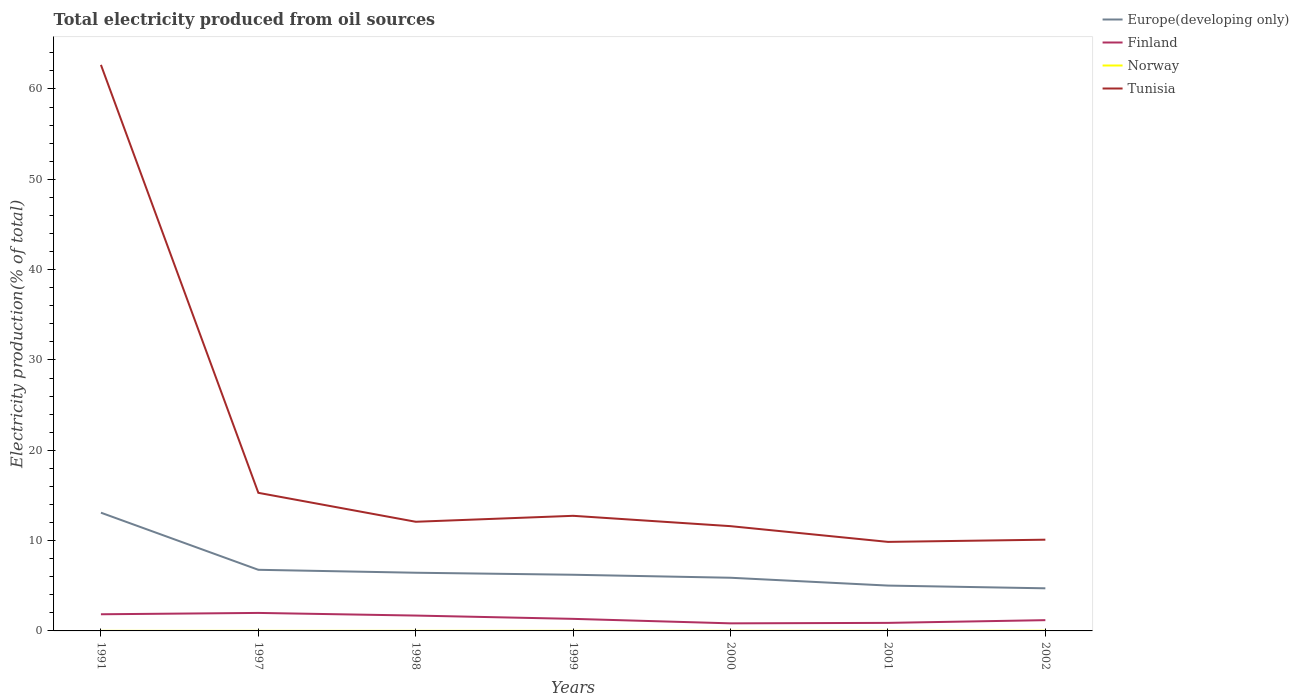How many different coloured lines are there?
Your answer should be very brief. 4. Does the line corresponding to Norway intersect with the line corresponding to Finland?
Keep it short and to the point. No. Across all years, what is the maximum total electricity produced in Norway?
Provide a short and direct response. 0.01. In which year was the total electricity produced in Tunisia maximum?
Give a very brief answer. 2001. What is the total total electricity produced in Finland in the graph?
Keep it short and to the point. -0.05. What is the difference between the highest and the second highest total electricity produced in Norway?
Provide a succinct answer. 0.01. What is the difference between the highest and the lowest total electricity produced in Tunisia?
Provide a short and direct response. 1. Is the total electricity produced in Europe(developing only) strictly greater than the total electricity produced in Norway over the years?
Provide a short and direct response. No. Are the values on the major ticks of Y-axis written in scientific E-notation?
Provide a succinct answer. No. Does the graph contain grids?
Your answer should be very brief. No. Where does the legend appear in the graph?
Offer a very short reply. Top right. How many legend labels are there?
Offer a terse response. 4. What is the title of the graph?
Ensure brevity in your answer.  Total electricity produced from oil sources. Does "Syrian Arab Republic" appear as one of the legend labels in the graph?
Your response must be concise. No. What is the label or title of the Y-axis?
Your answer should be compact. Electricity production(% of total). What is the Electricity production(% of total) of Europe(developing only) in 1991?
Your response must be concise. 13.09. What is the Electricity production(% of total) in Finland in 1991?
Make the answer very short. 1.84. What is the Electricity production(% of total) in Norway in 1991?
Your response must be concise. 0.01. What is the Electricity production(% of total) of Tunisia in 1991?
Provide a short and direct response. 62.67. What is the Electricity production(% of total) of Europe(developing only) in 1997?
Provide a succinct answer. 6.77. What is the Electricity production(% of total) of Finland in 1997?
Your answer should be very brief. 1.99. What is the Electricity production(% of total) of Norway in 1997?
Make the answer very short. 0.01. What is the Electricity production(% of total) in Tunisia in 1997?
Make the answer very short. 15.29. What is the Electricity production(% of total) in Europe(developing only) in 1998?
Provide a succinct answer. 6.44. What is the Electricity production(% of total) in Finland in 1998?
Keep it short and to the point. 1.7. What is the Electricity production(% of total) in Norway in 1998?
Provide a succinct answer. 0.01. What is the Electricity production(% of total) in Tunisia in 1998?
Provide a short and direct response. 12.09. What is the Electricity production(% of total) in Europe(developing only) in 1999?
Offer a very short reply. 6.22. What is the Electricity production(% of total) in Finland in 1999?
Keep it short and to the point. 1.34. What is the Electricity production(% of total) in Norway in 1999?
Your answer should be compact. 0.01. What is the Electricity production(% of total) of Tunisia in 1999?
Your answer should be very brief. 12.74. What is the Electricity production(% of total) of Europe(developing only) in 2000?
Your answer should be compact. 5.89. What is the Electricity production(% of total) of Finland in 2000?
Provide a succinct answer. 0.84. What is the Electricity production(% of total) of Norway in 2000?
Your answer should be compact. 0.01. What is the Electricity production(% of total) in Tunisia in 2000?
Your answer should be compact. 11.6. What is the Electricity production(% of total) in Europe(developing only) in 2001?
Make the answer very short. 5.02. What is the Electricity production(% of total) of Finland in 2001?
Offer a very short reply. 0.89. What is the Electricity production(% of total) in Norway in 2001?
Your response must be concise. 0.01. What is the Electricity production(% of total) of Tunisia in 2001?
Keep it short and to the point. 9.86. What is the Electricity production(% of total) of Europe(developing only) in 2002?
Your answer should be compact. 4.72. What is the Electricity production(% of total) of Finland in 2002?
Offer a terse response. 1.19. What is the Electricity production(% of total) in Norway in 2002?
Give a very brief answer. 0.02. What is the Electricity production(% of total) in Tunisia in 2002?
Your response must be concise. 10.1. Across all years, what is the maximum Electricity production(% of total) in Europe(developing only)?
Offer a terse response. 13.09. Across all years, what is the maximum Electricity production(% of total) in Finland?
Keep it short and to the point. 1.99. Across all years, what is the maximum Electricity production(% of total) in Norway?
Offer a terse response. 0.02. Across all years, what is the maximum Electricity production(% of total) in Tunisia?
Give a very brief answer. 62.67. Across all years, what is the minimum Electricity production(% of total) in Europe(developing only)?
Make the answer very short. 4.72. Across all years, what is the minimum Electricity production(% of total) of Finland?
Keep it short and to the point. 0.84. Across all years, what is the minimum Electricity production(% of total) in Norway?
Offer a terse response. 0.01. Across all years, what is the minimum Electricity production(% of total) of Tunisia?
Your answer should be compact. 9.86. What is the total Electricity production(% of total) of Europe(developing only) in the graph?
Offer a very short reply. 48.14. What is the total Electricity production(% of total) of Finland in the graph?
Your answer should be compact. 9.79. What is the total Electricity production(% of total) in Norway in the graph?
Keep it short and to the point. 0.06. What is the total Electricity production(% of total) in Tunisia in the graph?
Provide a short and direct response. 134.35. What is the difference between the Electricity production(% of total) of Europe(developing only) in 1991 and that in 1997?
Make the answer very short. 6.32. What is the difference between the Electricity production(% of total) in Finland in 1991 and that in 1997?
Offer a very short reply. -0.15. What is the difference between the Electricity production(% of total) of Norway in 1991 and that in 1997?
Your response must be concise. -0. What is the difference between the Electricity production(% of total) of Tunisia in 1991 and that in 1997?
Your answer should be compact. 47.38. What is the difference between the Electricity production(% of total) of Europe(developing only) in 1991 and that in 1998?
Ensure brevity in your answer.  6.65. What is the difference between the Electricity production(% of total) in Finland in 1991 and that in 1998?
Offer a very short reply. 0.14. What is the difference between the Electricity production(% of total) of Tunisia in 1991 and that in 1998?
Give a very brief answer. 50.58. What is the difference between the Electricity production(% of total) in Europe(developing only) in 1991 and that in 1999?
Keep it short and to the point. 6.87. What is the difference between the Electricity production(% of total) of Finland in 1991 and that in 1999?
Keep it short and to the point. 0.51. What is the difference between the Electricity production(% of total) of Norway in 1991 and that in 1999?
Provide a short and direct response. -0. What is the difference between the Electricity production(% of total) in Tunisia in 1991 and that in 1999?
Your answer should be compact. 49.93. What is the difference between the Electricity production(% of total) in Europe(developing only) in 1991 and that in 2000?
Your response must be concise. 7.2. What is the difference between the Electricity production(% of total) in Tunisia in 1991 and that in 2000?
Your answer should be very brief. 51.07. What is the difference between the Electricity production(% of total) in Europe(developing only) in 1991 and that in 2001?
Offer a terse response. 8.07. What is the difference between the Electricity production(% of total) of Finland in 1991 and that in 2001?
Give a very brief answer. 0.95. What is the difference between the Electricity production(% of total) of Norway in 1991 and that in 2001?
Provide a short and direct response. -0. What is the difference between the Electricity production(% of total) in Tunisia in 1991 and that in 2001?
Provide a succinct answer. 52.81. What is the difference between the Electricity production(% of total) in Europe(developing only) in 1991 and that in 2002?
Offer a very short reply. 8.37. What is the difference between the Electricity production(% of total) in Finland in 1991 and that in 2002?
Your response must be concise. 0.65. What is the difference between the Electricity production(% of total) in Norway in 1991 and that in 2002?
Offer a terse response. -0.01. What is the difference between the Electricity production(% of total) in Tunisia in 1991 and that in 2002?
Ensure brevity in your answer.  52.57. What is the difference between the Electricity production(% of total) in Europe(developing only) in 1997 and that in 1998?
Make the answer very short. 0.33. What is the difference between the Electricity production(% of total) of Finland in 1997 and that in 1998?
Provide a succinct answer. 0.29. What is the difference between the Electricity production(% of total) of Norway in 1997 and that in 1998?
Your response must be concise. 0. What is the difference between the Electricity production(% of total) of Tunisia in 1997 and that in 1998?
Give a very brief answer. 3.2. What is the difference between the Electricity production(% of total) in Europe(developing only) in 1997 and that in 1999?
Give a very brief answer. 0.55. What is the difference between the Electricity production(% of total) in Finland in 1997 and that in 1999?
Ensure brevity in your answer.  0.66. What is the difference between the Electricity production(% of total) in Norway in 1997 and that in 1999?
Give a very brief answer. -0. What is the difference between the Electricity production(% of total) in Tunisia in 1997 and that in 1999?
Make the answer very short. 2.55. What is the difference between the Electricity production(% of total) of Finland in 1997 and that in 2000?
Your response must be concise. 1.15. What is the difference between the Electricity production(% of total) in Norway in 1997 and that in 2000?
Offer a terse response. 0. What is the difference between the Electricity production(% of total) in Tunisia in 1997 and that in 2000?
Make the answer very short. 3.69. What is the difference between the Electricity production(% of total) in Europe(developing only) in 1997 and that in 2001?
Your answer should be very brief. 1.75. What is the difference between the Electricity production(% of total) of Finland in 1997 and that in 2001?
Give a very brief answer. 1.1. What is the difference between the Electricity production(% of total) in Norway in 1997 and that in 2001?
Your answer should be compact. -0. What is the difference between the Electricity production(% of total) in Tunisia in 1997 and that in 2001?
Offer a very short reply. 5.43. What is the difference between the Electricity production(% of total) of Europe(developing only) in 1997 and that in 2002?
Keep it short and to the point. 2.05. What is the difference between the Electricity production(% of total) in Finland in 1997 and that in 2002?
Give a very brief answer. 0.8. What is the difference between the Electricity production(% of total) in Norway in 1997 and that in 2002?
Your answer should be compact. -0.01. What is the difference between the Electricity production(% of total) of Tunisia in 1997 and that in 2002?
Offer a very short reply. 5.19. What is the difference between the Electricity production(% of total) of Europe(developing only) in 1998 and that in 1999?
Provide a succinct answer. 0.22. What is the difference between the Electricity production(% of total) of Finland in 1998 and that in 1999?
Ensure brevity in your answer.  0.36. What is the difference between the Electricity production(% of total) of Norway in 1998 and that in 1999?
Your answer should be very brief. -0. What is the difference between the Electricity production(% of total) of Tunisia in 1998 and that in 1999?
Ensure brevity in your answer.  -0.66. What is the difference between the Electricity production(% of total) of Europe(developing only) in 1998 and that in 2000?
Offer a very short reply. 0.55. What is the difference between the Electricity production(% of total) of Finland in 1998 and that in 2000?
Provide a short and direct response. 0.86. What is the difference between the Electricity production(% of total) of Norway in 1998 and that in 2000?
Provide a succinct answer. -0. What is the difference between the Electricity production(% of total) in Tunisia in 1998 and that in 2000?
Your answer should be compact. 0.49. What is the difference between the Electricity production(% of total) in Europe(developing only) in 1998 and that in 2001?
Your answer should be compact. 1.42. What is the difference between the Electricity production(% of total) of Finland in 1998 and that in 2001?
Your answer should be compact. 0.81. What is the difference between the Electricity production(% of total) of Norway in 1998 and that in 2001?
Make the answer very short. -0. What is the difference between the Electricity production(% of total) of Tunisia in 1998 and that in 2001?
Provide a short and direct response. 2.23. What is the difference between the Electricity production(% of total) of Europe(developing only) in 1998 and that in 2002?
Offer a very short reply. 1.72. What is the difference between the Electricity production(% of total) of Finland in 1998 and that in 2002?
Offer a very short reply. 0.51. What is the difference between the Electricity production(% of total) in Norway in 1998 and that in 2002?
Keep it short and to the point. -0.01. What is the difference between the Electricity production(% of total) in Tunisia in 1998 and that in 2002?
Provide a succinct answer. 1.99. What is the difference between the Electricity production(% of total) of Europe(developing only) in 1999 and that in 2000?
Your answer should be compact. 0.33. What is the difference between the Electricity production(% of total) in Finland in 1999 and that in 2000?
Your answer should be very brief. 0.5. What is the difference between the Electricity production(% of total) of Norway in 1999 and that in 2000?
Offer a terse response. 0. What is the difference between the Electricity production(% of total) of Tunisia in 1999 and that in 2000?
Your answer should be compact. 1.15. What is the difference between the Electricity production(% of total) in Europe(developing only) in 1999 and that in 2001?
Offer a terse response. 1.2. What is the difference between the Electricity production(% of total) in Finland in 1999 and that in 2001?
Your answer should be very brief. 0.44. What is the difference between the Electricity production(% of total) in Norway in 1999 and that in 2001?
Ensure brevity in your answer.  0. What is the difference between the Electricity production(% of total) of Tunisia in 1999 and that in 2001?
Give a very brief answer. 2.89. What is the difference between the Electricity production(% of total) in Europe(developing only) in 1999 and that in 2002?
Provide a short and direct response. 1.5. What is the difference between the Electricity production(% of total) in Finland in 1999 and that in 2002?
Provide a succinct answer. 0.14. What is the difference between the Electricity production(% of total) of Norway in 1999 and that in 2002?
Offer a terse response. -0.01. What is the difference between the Electricity production(% of total) of Tunisia in 1999 and that in 2002?
Give a very brief answer. 2.64. What is the difference between the Electricity production(% of total) of Europe(developing only) in 2000 and that in 2001?
Ensure brevity in your answer.  0.87. What is the difference between the Electricity production(% of total) of Finland in 2000 and that in 2001?
Provide a short and direct response. -0.05. What is the difference between the Electricity production(% of total) in Norway in 2000 and that in 2001?
Ensure brevity in your answer.  -0. What is the difference between the Electricity production(% of total) of Tunisia in 2000 and that in 2001?
Your answer should be very brief. 1.74. What is the difference between the Electricity production(% of total) of Europe(developing only) in 2000 and that in 2002?
Your answer should be compact. 1.17. What is the difference between the Electricity production(% of total) of Finland in 2000 and that in 2002?
Ensure brevity in your answer.  -0.35. What is the difference between the Electricity production(% of total) of Norway in 2000 and that in 2002?
Your answer should be compact. -0.01. What is the difference between the Electricity production(% of total) in Tunisia in 2000 and that in 2002?
Make the answer very short. 1.5. What is the difference between the Electricity production(% of total) of Europe(developing only) in 2001 and that in 2002?
Your answer should be compact. 0.3. What is the difference between the Electricity production(% of total) in Finland in 2001 and that in 2002?
Your response must be concise. -0.3. What is the difference between the Electricity production(% of total) of Norway in 2001 and that in 2002?
Your answer should be compact. -0.01. What is the difference between the Electricity production(% of total) of Tunisia in 2001 and that in 2002?
Give a very brief answer. -0.24. What is the difference between the Electricity production(% of total) of Europe(developing only) in 1991 and the Electricity production(% of total) of Finland in 1997?
Ensure brevity in your answer.  11.1. What is the difference between the Electricity production(% of total) of Europe(developing only) in 1991 and the Electricity production(% of total) of Norway in 1997?
Make the answer very short. 13.08. What is the difference between the Electricity production(% of total) of Europe(developing only) in 1991 and the Electricity production(% of total) of Tunisia in 1997?
Offer a terse response. -2.2. What is the difference between the Electricity production(% of total) in Finland in 1991 and the Electricity production(% of total) in Norway in 1997?
Make the answer very short. 1.84. What is the difference between the Electricity production(% of total) of Finland in 1991 and the Electricity production(% of total) of Tunisia in 1997?
Ensure brevity in your answer.  -13.45. What is the difference between the Electricity production(% of total) in Norway in 1991 and the Electricity production(% of total) in Tunisia in 1997?
Give a very brief answer. -15.28. What is the difference between the Electricity production(% of total) of Europe(developing only) in 1991 and the Electricity production(% of total) of Finland in 1998?
Your answer should be very brief. 11.39. What is the difference between the Electricity production(% of total) of Europe(developing only) in 1991 and the Electricity production(% of total) of Norway in 1998?
Provide a short and direct response. 13.08. What is the difference between the Electricity production(% of total) in Europe(developing only) in 1991 and the Electricity production(% of total) in Tunisia in 1998?
Provide a succinct answer. 1. What is the difference between the Electricity production(% of total) of Finland in 1991 and the Electricity production(% of total) of Norway in 1998?
Give a very brief answer. 1.84. What is the difference between the Electricity production(% of total) of Finland in 1991 and the Electricity production(% of total) of Tunisia in 1998?
Provide a short and direct response. -10.24. What is the difference between the Electricity production(% of total) in Norway in 1991 and the Electricity production(% of total) in Tunisia in 1998?
Give a very brief answer. -12.08. What is the difference between the Electricity production(% of total) in Europe(developing only) in 1991 and the Electricity production(% of total) in Finland in 1999?
Your response must be concise. 11.75. What is the difference between the Electricity production(% of total) of Europe(developing only) in 1991 and the Electricity production(% of total) of Norway in 1999?
Provide a short and direct response. 13.08. What is the difference between the Electricity production(% of total) of Europe(developing only) in 1991 and the Electricity production(% of total) of Tunisia in 1999?
Provide a succinct answer. 0.35. What is the difference between the Electricity production(% of total) of Finland in 1991 and the Electricity production(% of total) of Norway in 1999?
Provide a succinct answer. 1.84. What is the difference between the Electricity production(% of total) of Finland in 1991 and the Electricity production(% of total) of Tunisia in 1999?
Your answer should be compact. -10.9. What is the difference between the Electricity production(% of total) of Norway in 1991 and the Electricity production(% of total) of Tunisia in 1999?
Your answer should be very brief. -12.74. What is the difference between the Electricity production(% of total) in Europe(developing only) in 1991 and the Electricity production(% of total) in Finland in 2000?
Your response must be concise. 12.25. What is the difference between the Electricity production(% of total) in Europe(developing only) in 1991 and the Electricity production(% of total) in Norway in 2000?
Your response must be concise. 13.08. What is the difference between the Electricity production(% of total) in Europe(developing only) in 1991 and the Electricity production(% of total) in Tunisia in 2000?
Keep it short and to the point. 1.49. What is the difference between the Electricity production(% of total) in Finland in 1991 and the Electricity production(% of total) in Norway in 2000?
Your answer should be very brief. 1.84. What is the difference between the Electricity production(% of total) in Finland in 1991 and the Electricity production(% of total) in Tunisia in 2000?
Your answer should be compact. -9.76. What is the difference between the Electricity production(% of total) of Norway in 1991 and the Electricity production(% of total) of Tunisia in 2000?
Your answer should be compact. -11.59. What is the difference between the Electricity production(% of total) in Europe(developing only) in 1991 and the Electricity production(% of total) in Finland in 2001?
Your answer should be compact. 12.2. What is the difference between the Electricity production(% of total) of Europe(developing only) in 1991 and the Electricity production(% of total) of Norway in 2001?
Your answer should be compact. 13.08. What is the difference between the Electricity production(% of total) in Europe(developing only) in 1991 and the Electricity production(% of total) in Tunisia in 2001?
Ensure brevity in your answer.  3.23. What is the difference between the Electricity production(% of total) in Finland in 1991 and the Electricity production(% of total) in Norway in 2001?
Ensure brevity in your answer.  1.84. What is the difference between the Electricity production(% of total) in Finland in 1991 and the Electricity production(% of total) in Tunisia in 2001?
Your answer should be very brief. -8.01. What is the difference between the Electricity production(% of total) in Norway in 1991 and the Electricity production(% of total) in Tunisia in 2001?
Offer a very short reply. -9.85. What is the difference between the Electricity production(% of total) in Europe(developing only) in 1991 and the Electricity production(% of total) in Finland in 2002?
Your answer should be compact. 11.9. What is the difference between the Electricity production(% of total) of Europe(developing only) in 1991 and the Electricity production(% of total) of Norway in 2002?
Your answer should be very brief. 13.07. What is the difference between the Electricity production(% of total) in Europe(developing only) in 1991 and the Electricity production(% of total) in Tunisia in 2002?
Your answer should be very brief. 2.99. What is the difference between the Electricity production(% of total) in Finland in 1991 and the Electricity production(% of total) in Norway in 2002?
Provide a short and direct response. 1.83. What is the difference between the Electricity production(% of total) in Finland in 1991 and the Electricity production(% of total) in Tunisia in 2002?
Provide a short and direct response. -8.26. What is the difference between the Electricity production(% of total) in Norway in 1991 and the Electricity production(% of total) in Tunisia in 2002?
Ensure brevity in your answer.  -10.09. What is the difference between the Electricity production(% of total) of Europe(developing only) in 1997 and the Electricity production(% of total) of Finland in 1998?
Your answer should be compact. 5.07. What is the difference between the Electricity production(% of total) in Europe(developing only) in 1997 and the Electricity production(% of total) in Norway in 1998?
Provide a succinct answer. 6.76. What is the difference between the Electricity production(% of total) in Europe(developing only) in 1997 and the Electricity production(% of total) in Tunisia in 1998?
Offer a very short reply. -5.32. What is the difference between the Electricity production(% of total) of Finland in 1997 and the Electricity production(% of total) of Norway in 1998?
Your answer should be compact. 1.99. What is the difference between the Electricity production(% of total) in Finland in 1997 and the Electricity production(% of total) in Tunisia in 1998?
Provide a succinct answer. -10.09. What is the difference between the Electricity production(% of total) in Norway in 1997 and the Electricity production(% of total) in Tunisia in 1998?
Provide a succinct answer. -12.08. What is the difference between the Electricity production(% of total) in Europe(developing only) in 1997 and the Electricity production(% of total) in Finland in 1999?
Provide a succinct answer. 5.43. What is the difference between the Electricity production(% of total) of Europe(developing only) in 1997 and the Electricity production(% of total) of Norway in 1999?
Make the answer very short. 6.76. What is the difference between the Electricity production(% of total) in Europe(developing only) in 1997 and the Electricity production(% of total) in Tunisia in 1999?
Provide a succinct answer. -5.98. What is the difference between the Electricity production(% of total) of Finland in 1997 and the Electricity production(% of total) of Norway in 1999?
Give a very brief answer. 1.98. What is the difference between the Electricity production(% of total) of Finland in 1997 and the Electricity production(% of total) of Tunisia in 1999?
Your answer should be very brief. -10.75. What is the difference between the Electricity production(% of total) of Norway in 1997 and the Electricity production(% of total) of Tunisia in 1999?
Your response must be concise. -12.74. What is the difference between the Electricity production(% of total) in Europe(developing only) in 1997 and the Electricity production(% of total) in Finland in 2000?
Make the answer very short. 5.93. What is the difference between the Electricity production(% of total) in Europe(developing only) in 1997 and the Electricity production(% of total) in Norway in 2000?
Provide a short and direct response. 6.76. What is the difference between the Electricity production(% of total) of Europe(developing only) in 1997 and the Electricity production(% of total) of Tunisia in 2000?
Your response must be concise. -4.83. What is the difference between the Electricity production(% of total) in Finland in 1997 and the Electricity production(% of total) in Norway in 2000?
Ensure brevity in your answer.  1.99. What is the difference between the Electricity production(% of total) in Finland in 1997 and the Electricity production(% of total) in Tunisia in 2000?
Keep it short and to the point. -9.61. What is the difference between the Electricity production(% of total) in Norway in 1997 and the Electricity production(% of total) in Tunisia in 2000?
Your answer should be compact. -11.59. What is the difference between the Electricity production(% of total) in Europe(developing only) in 1997 and the Electricity production(% of total) in Finland in 2001?
Offer a terse response. 5.88. What is the difference between the Electricity production(% of total) in Europe(developing only) in 1997 and the Electricity production(% of total) in Norway in 2001?
Provide a short and direct response. 6.76. What is the difference between the Electricity production(% of total) of Europe(developing only) in 1997 and the Electricity production(% of total) of Tunisia in 2001?
Ensure brevity in your answer.  -3.09. What is the difference between the Electricity production(% of total) in Finland in 1997 and the Electricity production(% of total) in Norway in 2001?
Your response must be concise. 1.98. What is the difference between the Electricity production(% of total) of Finland in 1997 and the Electricity production(% of total) of Tunisia in 2001?
Your response must be concise. -7.87. What is the difference between the Electricity production(% of total) in Norway in 1997 and the Electricity production(% of total) in Tunisia in 2001?
Provide a short and direct response. -9.85. What is the difference between the Electricity production(% of total) in Europe(developing only) in 1997 and the Electricity production(% of total) in Finland in 2002?
Make the answer very short. 5.58. What is the difference between the Electricity production(% of total) of Europe(developing only) in 1997 and the Electricity production(% of total) of Norway in 2002?
Make the answer very short. 6.75. What is the difference between the Electricity production(% of total) of Europe(developing only) in 1997 and the Electricity production(% of total) of Tunisia in 2002?
Give a very brief answer. -3.33. What is the difference between the Electricity production(% of total) in Finland in 1997 and the Electricity production(% of total) in Norway in 2002?
Provide a short and direct response. 1.98. What is the difference between the Electricity production(% of total) of Finland in 1997 and the Electricity production(% of total) of Tunisia in 2002?
Your answer should be very brief. -8.11. What is the difference between the Electricity production(% of total) of Norway in 1997 and the Electricity production(% of total) of Tunisia in 2002?
Your answer should be very brief. -10.09. What is the difference between the Electricity production(% of total) of Europe(developing only) in 1998 and the Electricity production(% of total) of Finland in 1999?
Keep it short and to the point. 5.11. What is the difference between the Electricity production(% of total) of Europe(developing only) in 1998 and the Electricity production(% of total) of Norway in 1999?
Offer a terse response. 6.43. What is the difference between the Electricity production(% of total) of Europe(developing only) in 1998 and the Electricity production(% of total) of Tunisia in 1999?
Provide a short and direct response. -6.3. What is the difference between the Electricity production(% of total) in Finland in 1998 and the Electricity production(% of total) in Norway in 1999?
Give a very brief answer. 1.69. What is the difference between the Electricity production(% of total) in Finland in 1998 and the Electricity production(% of total) in Tunisia in 1999?
Ensure brevity in your answer.  -11.04. What is the difference between the Electricity production(% of total) of Norway in 1998 and the Electricity production(% of total) of Tunisia in 1999?
Your answer should be very brief. -12.74. What is the difference between the Electricity production(% of total) of Europe(developing only) in 1998 and the Electricity production(% of total) of Finland in 2000?
Offer a terse response. 5.6. What is the difference between the Electricity production(% of total) of Europe(developing only) in 1998 and the Electricity production(% of total) of Norway in 2000?
Your response must be concise. 6.44. What is the difference between the Electricity production(% of total) in Europe(developing only) in 1998 and the Electricity production(% of total) in Tunisia in 2000?
Ensure brevity in your answer.  -5.16. What is the difference between the Electricity production(% of total) of Finland in 1998 and the Electricity production(% of total) of Norway in 2000?
Your answer should be compact. 1.69. What is the difference between the Electricity production(% of total) of Finland in 1998 and the Electricity production(% of total) of Tunisia in 2000?
Give a very brief answer. -9.9. What is the difference between the Electricity production(% of total) in Norway in 1998 and the Electricity production(% of total) in Tunisia in 2000?
Offer a very short reply. -11.59. What is the difference between the Electricity production(% of total) in Europe(developing only) in 1998 and the Electricity production(% of total) in Finland in 2001?
Ensure brevity in your answer.  5.55. What is the difference between the Electricity production(% of total) of Europe(developing only) in 1998 and the Electricity production(% of total) of Norway in 2001?
Provide a short and direct response. 6.43. What is the difference between the Electricity production(% of total) in Europe(developing only) in 1998 and the Electricity production(% of total) in Tunisia in 2001?
Provide a short and direct response. -3.42. What is the difference between the Electricity production(% of total) in Finland in 1998 and the Electricity production(% of total) in Norway in 2001?
Provide a short and direct response. 1.69. What is the difference between the Electricity production(% of total) of Finland in 1998 and the Electricity production(% of total) of Tunisia in 2001?
Your answer should be very brief. -8.16. What is the difference between the Electricity production(% of total) of Norway in 1998 and the Electricity production(% of total) of Tunisia in 2001?
Provide a short and direct response. -9.85. What is the difference between the Electricity production(% of total) in Europe(developing only) in 1998 and the Electricity production(% of total) in Finland in 2002?
Make the answer very short. 5.25. What is the difference between the Electricity production(% of total) of Europe(developing only) in 1998 and the Electricity production(% of total) of Norway in 2002?
Offer a very short reply. 6.42. What is the difference between the Electricity production(% of total) in Europe(developing only) in 1998 and the Electricity production(% of total) in Tunisia in 2002?
Make the answer very short. -3.66. What is the difference between the Electricity production(% of total) in Finland in 1998 and the Electricity production(% of total) in Norway in 2002?
Provide a succinct answer. 1.68. What is the difference between the Electricity production(% of total) of Finland in 1998 and the Electricity production(% of total) of Tunisia in 2002?
Provide a succinct answer. -8.4. What is the difference between the Electricity production(% of total) in Norway in 1998 and the Electricity production(% of total) in Tunisia in 2002?
Provide a short and direct response. -10.09. What is the difference between the Electricity production(% of total) of Europe(developing only) in 1999 and the Electricity production(% of total) of Finland in 2000?
Provide a succinct answer. 5.38. What is the difference between the Electricity production(% of total) in Europe(developing only) in 1999 and the Electricity production(% of total) in Norway in 2000?
Provide a succinct answer. 6.21. What is the difference between the Electricity production(% of total) in Europe(developing only) in 1999 and the Electricity production(% of total) in Tunisia in 2000?
Give a very brief answer. -5.38. What is the difference between the Electricity production(% of total) in Finland in 1999 and the Electricity production(% of total) in Norway in 2000?
Your answer should be compact. 1.33. What is the difference between the Electricity production(% of total) of Finland in 1999 and the Electricity production(% of total) of Tunisia in 2000?
Your answer should be very brief. -10.26. What is the difference between the Electricity production(% of total) of Norway in 1999 and the Electricity production(% of total) of Tunisia in 2000?
Your response must be concise. -11.59. What is the difference between the Electricity production(% of total) of Europe(developing only) in 1999 and the Electricity production(% of total) of Finland in 2001?
Your response must be concise. 5.33. What is the difference between the Electricity production(% of total) of Europe(developing only) in 1999 and the Electricity production(% of total) of Norway in 2001?
Give a very brief answer. 6.21. What is the difference between the Electricity production(% of total) of Europe(developing only) in 1999 and the Electricity production(% of total) of Tunisia in 2001?
Provide a short and direct response. -3.64. What is the difference between the Electricity production(% of total) of Finland in 1999 and the Electricity production(% of total) of Norway in 2001?
Give a very brief answer. 1.33. What is the difference between the Electricity production(% of total) in Finland in 1999 and the Electricity production(% of total) in Tunisia in 2001?
Make the answer very short. -8.52. What is the difference between the Electricity production(% of total) in Norway in 1999 and the Electricity production(% of total) in Tunisia in 2001?
Provide a short and direct response. -9.85. What is the difference between the Electricity production(% of total) in Europe(developing only) in 1999 and the Electricity production(% of total) in Finland in 2002?
Provide a succinct answer. 5.03. What is the difference between the Electricity production(% of total) of Europe(developing only) in 1999 and the Electricity production(% of total) of Norway in 2002?
Provide a short and direct response. 6.2. What is the difference between the Electricity production(% of total) in Europe(developing only) in 1999 and the Electricity production(% of total) in Tunisia in 2002?
Keep it short and to the point. -3.88. What is the difference between the Electricity production(% of total) of Finland in 1999 and the Electricity production(% of total) of Norway in 2002?
Keep it short and to the point. 1.32. What is the difference between the Electricity production(% of total) in Finland in 1999 and the Electricity production(% of total) in Tunisia in 2002?
Ensure brevity in your answer.  -8.76. What is the difference between the Electricity production(% of total) in Norway in 1999 and the Electricity production(% of total) in Tunisia in 2002?
Make the answer very short. -10.09. What is the difference between the Electricity production(% of total) in Europe(developing only) in 2000 and the Electricity production(% of total) in Finland in 2001?
Your response must be concise. 5. What is the difference between the Electricity production(% of total) of Europe(developing only) in 2000 and the Electricity production(% of total) of Norway in 2001?
Provide a short and direct response. 5.88. What is the difference between the Electricity production(% of total) in Europe(developing only) in 2000 and the Electricity production(% of total) in Tunisia in 2001?
Offer a very short reply. -3.97. What is the difference between the Electricity production(% of total) in Finland in 2000 and the Electricity production(% of total) in Norway in 2001?
Give a very brief answer. 0.83. What is the difference between the Electricity production(% of total) of Finland in 2000 and the Electricity production(% of total) of Tunisia in 2001?
Offer a terse response. -9.02. What is the difference between the Electricity production(% of total) in Norway in 2000 and the Electricity production(% of total) in Tunisia in 2001?
Keep it short and to the point. -9.85. What is the difference between the Electricity production(% of total) in Europe(developing only) in 2000 and the Electricity production(% of total) in Finland in 2002?
Offer a very short reply. 4.7. What is the difference between the Electricity production(% of total) of Europe(developing only) in 2000 and the Electricity production(% of total) of Norway in 2002?
Your answer should be compact. 5.87. What is the difference between the Electricity production(% of total) of Europe(developing only) in 2000 and the Electricity production(% of total) of Tunisia in 2002?
Offer a very short reply. -4.21. What is the difference between the Electricity production(% of total) of Finland in 2000 and the Electricity production(% of total) of Norway in 2002?
Provide a short and direct response. 0.82. What is the difference between the Electricity production(% of total) of Finland in 2000 and the Electricity production(% of total) of Tunisia in 2002?
Provide a short and direct response. -9.26. What is the difference between the Electricity production(% of total) of Norway in 2000 and the Electricity production(% of total) of Tunisia in 2002?
Offer a very short reply. -10.09. What is the difference between the Electricity production(% of total) of Europe(developing only) in 2001 and the Electricity production(% of total) of Finland in 2002?
Your answer should be compact. 3.83. What is the difference between the Electricity production(% of total) of Europe(developing only) in 2001 and the Electricity production(% of total) of Norway in 2002?
Make the answer very short. 5. What is the difference between the Electricity production(% of total) of Europe(developing only) in 2001 and the Electricity production(% of total) of Tunisia in 2002?
Offer a very short reply. -5.08. What is the difference between the Electricity production(% of total) in Finland in 2001 and the Electricity production(% of total) in Norway in 2002?
Make the answer very short. 0.87. What is the difference between the Electricity production(% of total) in Finland in 2001 and the Electricity production(% of total) in Tunisia in 2002?
Give a very brief answer. -9.21. What is the difference between the Electricity production(% of total) of Norway in 2001 and the Electricity production(% of total) of Tunisia in 2002?
Offer a terse response. -10.09. What is the average Electricity production(% of total) in Europe(developing only) per year?
Ensure brevity in your answer.  6.88. What is the average Electricity production(% of total) of Finland per year?
Offer a very short reply. 1.4. What is the average Electricity production(% of total) in Norway per year?
Ensure brevity in your answer.  0.01. What is the average Electricity production(% of total) in Tunisia per year?
Offer a terse response. 19.19. In the year 1991, what is the difference between the Electricity production(% of total) in Europe(developing only) and Electricity production(% of total) in Finland?
Keep it short and to the point. 11.25. In the year 1991, what is the difference between the Electricity production(% of total) of Europe(developing only) and Electricity production(% of total) of Norway?
Provide a succinct answer. 13.08. In the year 1991, what is the difference between the Electricity production(% of total) of Europe(developing only) and Electricity production(% of total) of Tunisia?
Offer a terse response. -49.58. In the year 1991, what is the difference between the Electricity production(% of total) of Finland and Electricity production(% of total) of Norway?
Give a very brief answer. 1.84. In the year 1991, what is the difference between the Electricity production(% of total) in Finland and Electricity production(% of total) in Tunisia?
Give a very brief answer. -60.83. In the year 1991, what is the difference between the Electricity production(% of total) in Norway and Electricity production(% of total) in Tunisia?
Offer a terse response. -62.66. In the year 1997, what is the difference between the Electricity production(% of total) of Europe(developing only) and Electricity production(% of total) of Finland?
Your answer should be very brief. 4.78. In the year 1997, what is the difference between the Electricity production(% of total) of Europe(developing only) and Electricity production(% of total) of Norway?
Give a very brief answer. 6.76. In the year 1997, what is the difference between the Electricity production(% of total) of Europe(developing only) and Electricity production(% of total) of Tunisia?
Your answer should be very brief. -8.52. In the year 1997, what is the difference between the Electricity production(% of total) of Finland and Electricity production(% of total) of Norway?
Provide a succinct answer. 1.98. In the year 1997, what is the difference between the Electricity production(% of total) of Finland and Electricity production(% of total) of Tunisia?
Keep it short and to the point. -13.3. In the year 1997, what is the difference between the Electricity production(% of total) in Norway and Electricity production(% of total) in Tunisia?
Offer a very short reply. -15.28. In the year 1998, what is the difference between the Electricity production(% of total) in Europe(developing only) and Electricity production(% of total) in Finland?
Make the answer very short. 4.74. In the year 1998, what is the difference between the Electricity production(% of total) in Europe(developing only) and Electricity production(% of total) in Norway?
Your answer should be very brief. 6.44. In the year 1998, what is the difference between the Electricity production(% of total) in Europe(developing only) and Electricity production(% of total) in Tunisia?
Offer a terse response. -5.64. In the year 1998, what is the difference between the Electricity production(% of total) of Finland and Electricity production(% of total) of Norway?
Make the answer very short. 1.69. In the year 1998, what is the difference between the Electricity production(% of total) of Finland and Electricity production(% of total) of Tunisia?
Make the answer very short. -10.39. In the year 1998, what is the difference between the Electricity production(% of total) in Norway and Electricity production(% of total) in Tunisia?
Offer a very short reply. -12.08. In the year 1999, what is the difference between the Electricity production(% of total) of Europe(developing only) and Electricity production(% of total) of Finland?
Provide a short and direct response. 4.88. In the year 1999, what is the difference between the Electricity production(% of total) of Europe(developing only) and Electricity production(% of total) of Norway?
Provide a succinct answer. 6.21. In the year 1999, what is the difference between the Electricity production(% of total) in Europe(developing only) and Electricity production(% of total) in Tunisia?
Give a very brief answer. -6.53. In the year 1999, what is the difference between the Electricity production(% of total) of Finland and Electricity production(% of total) of Norway?
Offer a very short reply. 1.33. In the year 1999, what is the difference between the Electricity production(% of total) in Finland and Electricity production(% of total) in Tunisia?
Provide a succinct answer. -11.41. In the year 1999, what is the difference between the Electricity production(% of total) of Norway and Electricity production(% of total) of Tunisia?
Your response must be concise. -12.74. In the year 2000, what is the difference between the Electricity production(% of total) of Europe(developing only) and Electricity production(% of total) of Finland?
Give a very brief answer. 5.05. In the year 2000, what is the difference between the Electricity production(% of total) in Europe(developing only) and Electricity production(% of total) in Norway?
Ensure brevity in your answer.  5.88. In the year 2000, what is the difference between the Electricity production(% of total) of Europe(developing only) and Electricity production(% of total) of Tunisia?
Offer a very short reply. -5.71. In the year 2000, what is the difference between the Electricity production(% of total) in Finland and Electricity production(% of total) in Norway?
Your answer should be compact. 0.83. In the year 2000, what is the difference between the Electricity production(% of total) of Finland and Electricity production(% of total) of Tunisia?
Give a very brief answer. -10.76. In the year 2000, what is the difference between the Electricity production(% of total) of Norway and Electricity production(% of total) of Tunisia?
Your response must be concise. -11.59. In the year 2001, what is the difference between the Electricity production(% of total) of Europe(developing only) and Electricity production(% of total) of Finland?
Your response must be concise. 4.13. In the year 2001, what is the difference between the Electricity production(% of total) in Europe(developing only) and Electricity production(% of total) in Norway?
Your answer should be compact. 5.01. In the year 2001, what is the difference between the Electricity production(% of total) of Europe(developing only) and Electricity production(% of total) of Tunisia?
Give a very brief answer. -4.84. In the year 2001, what is the difference between the Electricity production(% of total) in Finland and Electricity production(% of total) in Norway?
Keep it short and to the point. 0.88. In the year 2001, what is the difference between the Electricity production(% of total) in Finland and Electricity production(% of total) in Tunisia?
Ensure brevity in your answer.  -8.97. In the year 2001, what is the difference between the Electricity production(% of total) in Norway and Electricity production(% of total) in Tunisia?
Provide a short and direct response. -9.85. In the year 2002, what is the difference between the Electricity production(% of total) of Europe(developing only) and Electricity production(% of total) of Finland?
Your response must be concise. 3.53. In the year 2002, what is the difference between the Electricity production(% of total) in Europe(developing only) and Electricity production(% of total) in Norway?
Your response must be concise. 4.7. In the year 2002, what is the difference between the Electricity production(% of total) in Europe(developing only) and Electricity production(% of total) in Tunisia?
Your answer should be compact. -5.38. In the year 2002, what is the difference between the Electricity production(% of total) in Finland and Electricity production(% of total) in Norway?
Your answer should be compact. 1.17. In the year 2002, what is the difference between the Electricity production(% of total) of Finland and Electricity production(% of total) of Tunisia?
Offer a terse response. -8.91. In the year 2002, what is the difference between the Electricity production(% of total) of Norway and Electricity production(% of total) of Tunisia?
Provide a succinct answer. -10.08. What is the ratio of the Electricity production(% of total) of Europe(developing only) in 1991 to that in 1997?
Offer a terse response. 1.93. What is the ratio of the Electricity production(% of total) of Finland in 1991 to that in 1997?
Give a very brief answer. 0.93. What is the ratio of the Electricity production(% of total) in Norway in 1991 to that in 1997?
Your response must be concise. 0.87. What is the ratio of the Electricity production(% of total) of Tunisia in 1991 to that in 1997?
Your answer should be very brief. 4.1. What is the ratio of the Electricity production(% of total) of Europe(developing only) in 1991 to that in 1998?
Offer a terse response. 2.03. What is the ratio of the Electricity production(% of total) of Finland in 1991 to that in 1998?
Keep it short and to the point. 1.08. What is the ratio of the Electricity production(% of total) in Norway in 1991 to that in 1998?
Provide a succinct answer. 1.05. What is the ratio of the Electricity production(% of total) in Tunisia in 1991 to that in 1998?
Your response must be concise. 5.19. What is the ratio of the Electricity production(% of total) of Europe(developing only) in 1991 to that in 1999?
Offer a terse response. 2.1. What is the ratio of the Electricity production(% of total) of Finland in 1991 to that in 1999?
Provide a succinct answer. 1.38. What is the ratio of the Electricity production(% of total) in Norway in 1991 to that in 1999?
Provide a short and direct response. 0.77. What is the ratio of the Electricity production(% of total) in Tunisia in 1991 to that in 1999?
Make the answer very short. 4.92. What is the ratio of the Electricity production(% of total) of Europe(developing only) in 1991 to that in 2000?
Give a very brief answer. 2.22. What is the ratio of the Electricity production(% of total) in Finland in 1991 to that in 2000?
Give a very brief answer. 2.2. What is the ratio of the Electricity production(% of total) of Norway in 1991 to that in 2000?
Ensure brevity in your answer.  1. What is the ratio of the Electricity production(% of total) of Tunisia in 1991 to that in 2000?
Offer a very short reply. 5.4. What is the ratio of the Electricity production(% of total) in Europe(developing only) in 1991 to that in 2001?
Your response must be concise. 2.61. What is the ratio of the Electricity production(% of total) in Finland in 1991 to that in 2001?
Your answer should be compact. 2.07. What is the ratio of the Electricity production(% of total) in Norway in 1991 to that in 2001?
Your answer should be compact. 0.85. What is the ratio of the Electricity production(% of total) of Tunisia in 1991 to that in 2001?
Provide a short and direct response. 6.36. What is the ratio of the Electricity production(% of total) in Europe(developing only) in 1991 to that in 2002?
Your answer should be compact. 2.78. What is the ratio of the Electricity production(% of total) of Finland in 1991 to that in 2002?
Your answer should be compact. 1.55. What is the ratio of the Electricity production(% of total) in Norway in 1991 to that in 2002?
Provide a succinct answer. 0.37. What is the ratio of the Electricity production(% of total) of Tunisia in 1991 to that in 2002?
Keep it short and to the point. 6.2. What is the ratio of the Electricity production(% of total) in Europe(developing only) in 1997 to that in 1998?
Make the answer very short. 1.05. What is the ratio of the Electricity production(% of total) of Finland in 1997 to that in 1998?
Ensure brevity in your answer.  1.17. What is the ratio of the Electricity production(% of total) in Norway in 1997 to that in 1998?
Give a very brief answer. 1.2. What is the ratio of the Electricity production(% of total) of Tunisia in 1997 to that in 1998?
Provide a short and direct response. 1.27. What is the ratio of the Electricity production(% of total) of Europe(developing only) in 1997 to that in 1999?
Your response must be concise. 1.09. What is the ratio of the Electricity production(% of total) of Finland in 1997 to that in 1999?
Offer a very short reply. 1.49. What is the ratio of the Electricity production(% of total) in Norway in 1997 to that in 1999?
Provide a succinct answer. 0.89. What is the ratio of the Electricity production(% of total) of Tunisia in 1997 to that in 1999?
Provide a short and direct response. 1.2. What is the ratio of the Electricity production(% of total) in Europe(developing only) in 1997 to that in 2000?
Provide a succinct answer. 1.15. What is the ratio of the Electricity production(% of total) of Finland in 1997 to that in 2000?
Make the answer very short. 2.37. What is the ratio of the Electricity production(% of total) of Norway in 1997 to that in 2000?
Your answer should be compact. 1.15. What is the ratio of the Electricity production(% of total) of Tunisia in 1997 to that in 2000?
Give a very brief answer. 1.32. What is the ratio of the Electricity production(% of total) in Europe(developing only) in 1997 to that in 2001?
Offer a very short reply. 1.35. What is the ratio of the Electricity production(% of total) in Finland in 1997 to that in 2001?
Offer a very short reply. 2.23. What is the ratio of the Electricity production(% of total) in Norway in 1997 to that in 2001?
Your answer should be very brief. 0.98. What is the ratio of the Electricity production(% of total) in Tunisia in 1997 to that in 2001?
Your answer should be very brief. 1.55. What is the ratio of the Electricity production(% of total) of Europe(developing only) in 1997 to that in 2002?
Your answer should be very brief. 1.43. What is the ratio of the Electricity production(% of total) of Finland in 1997 to that in 2002?
Ensure brevity in your answer.  1.67. What is the ratio of the Electricity production(% of total) of Norway in 1997 to that in 2002?
Ensure brevity in your answer.  0.43. What is the ratio of the Electricity production(% of total) in Tunisia in 1997 to that in 2002?
Your answer should be compact. 1.51. What is the ratio of the Electricity production(% of total) in Europe(developing only) in 1998 to that in 1999?
Your answer should be very brief. 1.04. What is the ratio of the Electricity production(% of total) of Finland in 1998 to that in 1999?
Your answer should be very brief. 1.27. What is the ratio of the Electricity production(% of total) in Norway in 1998 to that in 1999?
Provide a succinct answer. 0.74. What is the ratio of the Electricity production(% of total) in Tunisia in 1998 to that in 1999?
Provide a succinct answer. 0.95. What is the ratio of the Electricity production(% of total) of Europe(developing only) in 1998 to that in 2000?
Keep it short and to the point. 1.09. What is the ratio of the Electricity production(% of total) in Finland in 1998 to that in 2000?
Give a very brief answer. 2.03. What is the ratio of the Electricity production(% of total) in Tunisia in 1998 to that in 2000?
Your answer should be compact. 1.04. What is the ratio of the Electricity production(% of total) in Europe(developing only) in 1998 to that in 2001?
Ensure brevity in your answer.  1.28. What is the ratio of the Electricity production(% of total) in Finland in 1998 to that in 2001?
Make the answer very short. 1.91. What is the ratio of the Electricity production(% of total) of Norway in 1998 to that in 2001?
Your answer should be compact. 0.81. What is the ratio of the Electricity production(% of total) of Tunisia in 1998 to that in 2001?
Provide a short and direct response. 1.23. What is the ratio of the Electricity production(% of total) in Europe(developing only) in 1998 to that in 2002?
Provide a short and direct response. 1.37. What is the ratio of the Electricity production(% of total) of Finland in 1998 to that in 2002?
Provide a short and direct response. 1.43. What is the ratio of the Electricity production(% of total) of Norway in 1998 to that in 2002?
Provide a succinct answer. 0.36. What is the ratio of the Electricity production(% of total) of Tunisia in 1998 to that in 2002?
Provide a short and direct response. 1.2. What is the ratio of the Electricity production(% of total) in Europe(developing only) in 1999 to that in 2000?
Offer a terse response. 1.06. What is the ratio of the Electricity production(% of total) of Finland in 1999 to that in 2000?
Make the answer very short. 1.59. What is the ratio of the Electricity production(% of total) of Norway in 1999 to that in 2000?
Keep it short and to the point. 1.29. What is the ratio of the Electricity production(% of total) of Tunisia in 1999 to that in 2000?
Provide a succinct answer. 1.1. What is the ratio of the Electricity production(% of total) in Europe(developing only) in 1999 to that in 2001?
Offer a terse response. 1.24. What is the ratio of the Electricity production(% of total) of Finland in 1999 to that in 2001?
Make the answer very short. 1.5. What is the ratio of the Electricity production(% of total) of Norway in 1999 to that in 2001?
Offer a very short reply. 1.1. What is the ratio of the Electricity production(% of total) in Tunisia in 1999 to that in 2001?
Offer a very short reply. 1.29. What is the ratio of the Electricity production(% of total) in Europe(developing only) in 1999 to that in 2002?
Give a very brief answer. 1.32. What is the ratio of the Electricity production(% of total) in Finland in 1999 to that in 2002?
Ensure brevity in your answer.  1.12. What is the ratio of the Electricity production(% of total) of Norway in 1999 to that in 2002?
Provide a succinct answer. 0.48. What is the ratio of the Electricity production(% of total) of Tunisia in 1999 to that in 2002?
Offer a very short reply. 1.26. What is the ratio of the Electricity production(% of total) in Europe(developing only) in 2000 to that in 2001?
Your answer should be very brief. 1.17. What is the ratio of the Electricity production(% of total) of Finland in 2000 to that in 2001?
Your answer should be compact. 0.94. What is the ratio of the Electricity production(% of total) in Norway in 2000 to that in 2001?
Offer a terse response. 0.85. What is the ratio of the Electricity production(% of total) in Tunisia in 2000 to that in 2001?
Provide a short and direct response. 1.18. What is the ratio of the Electricity production(% of total) of Europe(developing only) in 2000 to that in 2002?
Make the answer very short. 1.25. What is the ratio of the Electricity production(% of total) in Finland in 2000 to that in 2002?
Provide a short and direct response. 0.7. What is the ratio of the Electricity production(% of total) in Norway in 2000 to that in 2002?
Provide a succinct answer. 0.37. What is the ratio of the Electricity production(% of total) of Tunisia in 2000 to that in 2002?
Offer a very short reply. 1.15. What is the ratio of the Electricity production(% of total) in Europe(developing only) in 2001 to that in 2002?
Offer a very short reply. 1.06. What is the ratio of the Electricity production(% of total) in Finland in 2001 to that in 2002?
Your answer should be compact. 0.75. What is the ratio of the Electricity production(% of total) in Norway in 2001 to that in 2002?
Your answer should be very brief. 0.44. What is the ratio of the Electricity production(% of total) in Tunisia in 2001 to that in 2002?
Keep it short and to the point. 0.98. What is the difference between the highest and the second highest Electricity production(% of total) of Europe(developing only)?
Your answer should be very brief. 6.32. What is the difference between the highest and the second highest Electricity production(% of total) of Finland?
Make the answer very short. 0.15. What is the difference between the highest and the second highest Electricity production(% of total) of Norway?
Ensure brevity in your answer.  0.01. What is the difference between the highest and the second highest Electricity production(% of total) in Tunisia?
Provide a short and direct response. 47.38. What is the difference between the highest and the lowest Electricity production(% of total) in Europe(developing only)?
Your answer should be very brief. 8.37. What is the difference between the highest and the lowest Electricity production(% of total) in Finland?
Offer a terse response. 1.15. What is the difference between the highest and the lowest Electricity production(% of total) of Norway?
Offer a very short reply. 0.01. What is the difference between the highest and the lowest Electricity production(% of total) of Tunisia?
Provide a succinct answer. 52.81. 